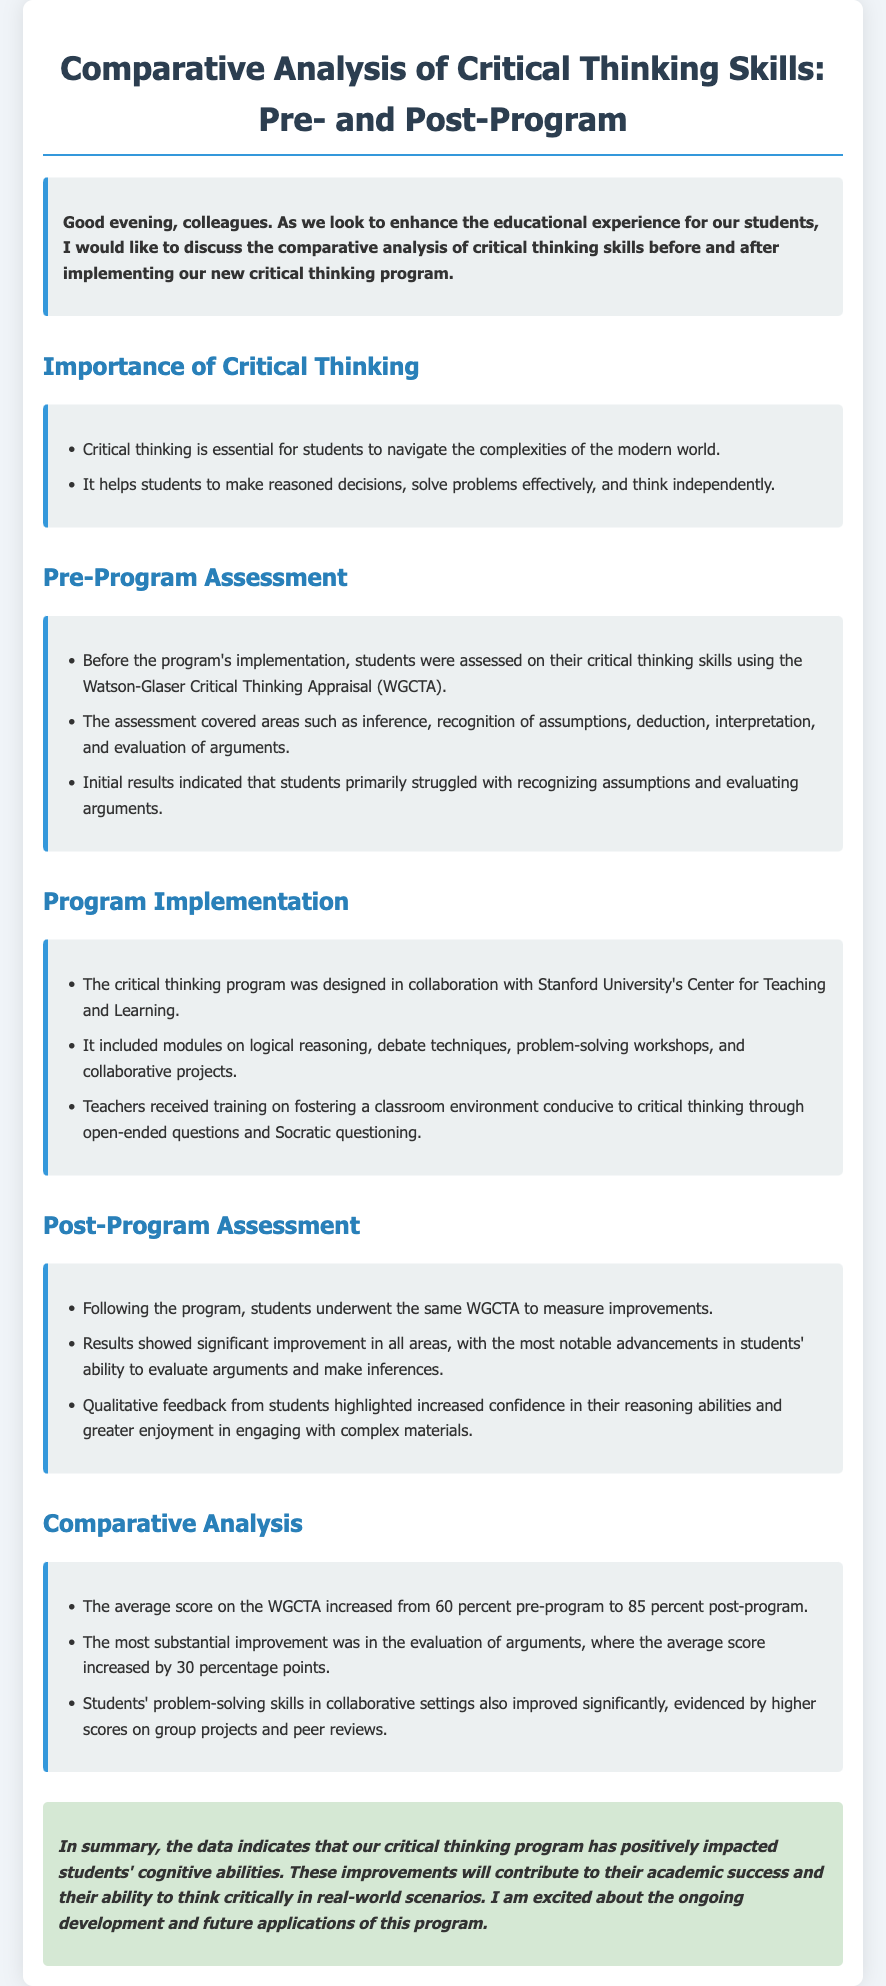What assessment tool was used for pre-program evaluation? The document states that the Watson-Glaser Critical Thinking Appraisal (WGCTA) was used for pre-program evaluation.
Answer: Watson-Glaser Critical Thinking Appraisal What was the most substantial area of improvement post-program? The analysis highlights that the most substantial improvement was in the evaluation of arguments, increasing by 30 percentage points.
Answer: Evaluation of arguments What percentage did the average WGCTA score rise to after the program? The document mentions that the average score on the WGCTA increased from 60 percent pre-program to 85 percent post-program.
Answer: 85 percent Who collaborated on the design of the critical thinking program? The program was designed in collaboration with Stanford University's Center for Teaching and Learning.
Answer: Stanford University's Center for Teaching and Learning What type of feedback did students provide after the program? Students provided qualitative feedback highlighting increased confidence in their reasoning abilities and greater enjoyment in engaging with complex materials.
Answer: Increased confidence and enjoyment What skills were specifically targeted in the critical thinking program? The program included modules on logical reasoning, debate techniques, problem-solving workshops, and collaborative projects targeting various critical thinking skills.
Answer: Logical reasoning, debate techniques, problem-solving workshops, collaborative projects What was indicated about problem-solving skills after the program? The results indicated that students' problem-solving skills in collaborative settings improved significantly, evidenced by higher scores on group projects and peer reviews.
Answer: Improved significantly What was a key characteristic of the learning environment promoted by the program? The program promoted a classroom environment conducive to critical thinking through open-ended questions and Socratic questioning.
Answer: Open-ended questions and Socratic questioning What is the overall conclusion about the critical thinking program's impact? The conclusion states that the data indicates the critical thinking program positively impacted students' cognitive abilities.
Answer: Positively impacted cognitive abilities 